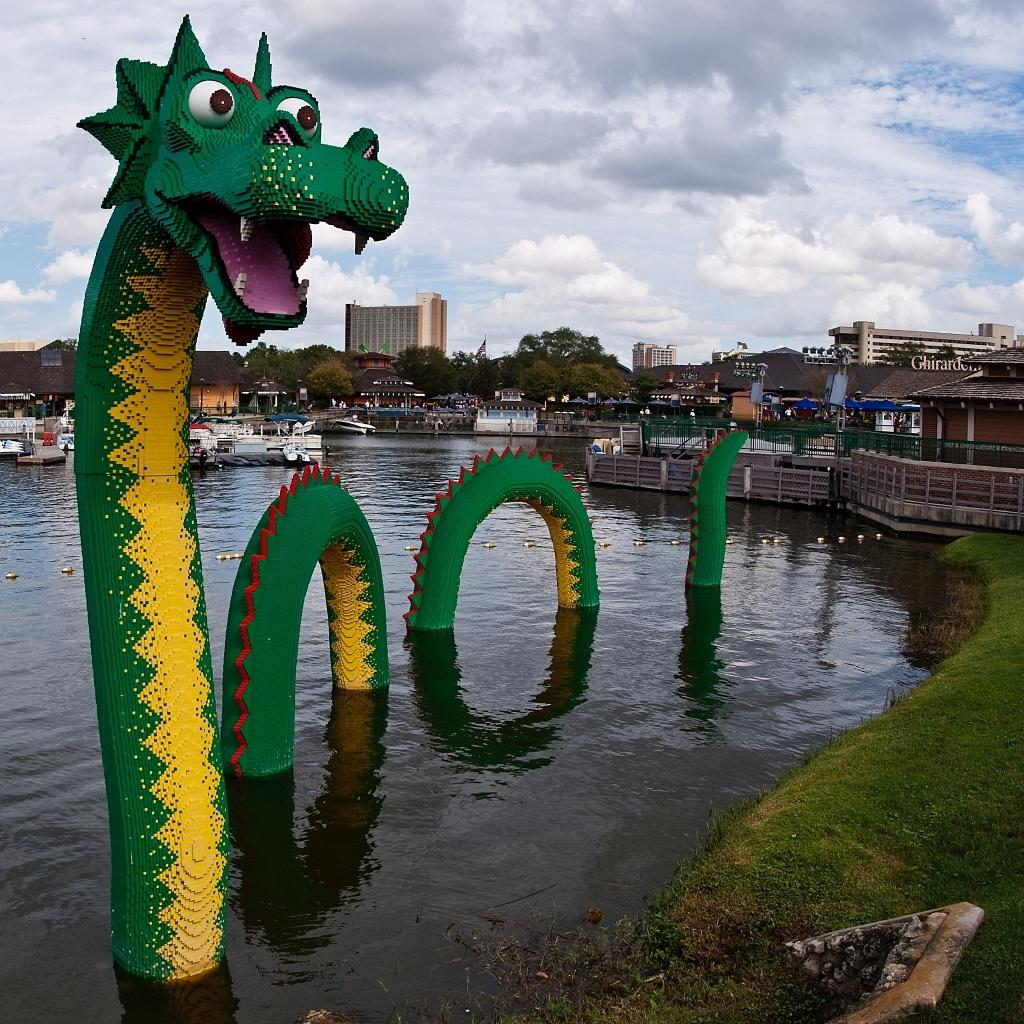What type of structures can be seen in the image? There are buildings in the image. What natural elements are present in the image? There are trees in the image. What type of barrier can be seen in the image? There is fencing in the image. What part of the natural environment is visible in the image? The sky is visible in the image. What type of vehicles are on the water surface in the image? There are ships on the water surface in the image. What type of toy is present in the water? There is a toy animal in the water. What is the profit margin of the government in the image? There is no mention of profit or government in the image; it features buildings, trees, fencing, the sky, ships, and a toy animal. Can you tell me how many monkeys are climbing the trees in the image? There are no monkeys present in the image; it features trees, but no animals are visible. 